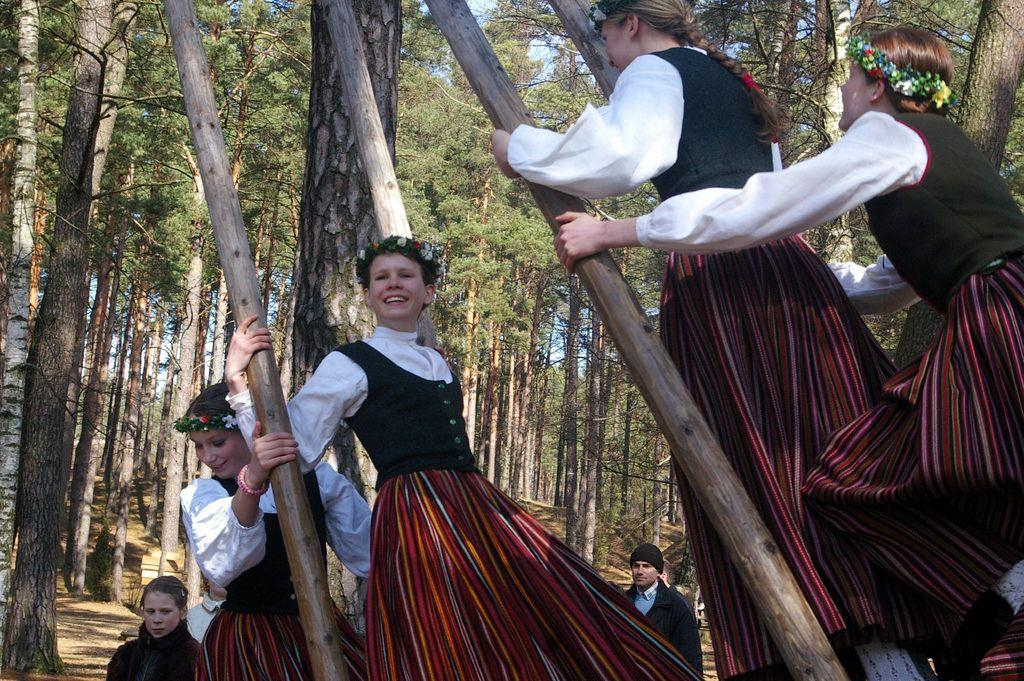What can be seen in the image? There are people standing in the image. What is visible in the background of the image? There are trees in the background of the image. What objects are in the middle of the image? There are wooden sticks in the middle of the image. What is visible at the top of the image? The sky is visible at the top of the image. What type of furniture can be seen in the image? There is no furniture present in the image. How many tomatoes are being held by the people in the image? There are no tomatoes visible in the image; the people are not holding any. 